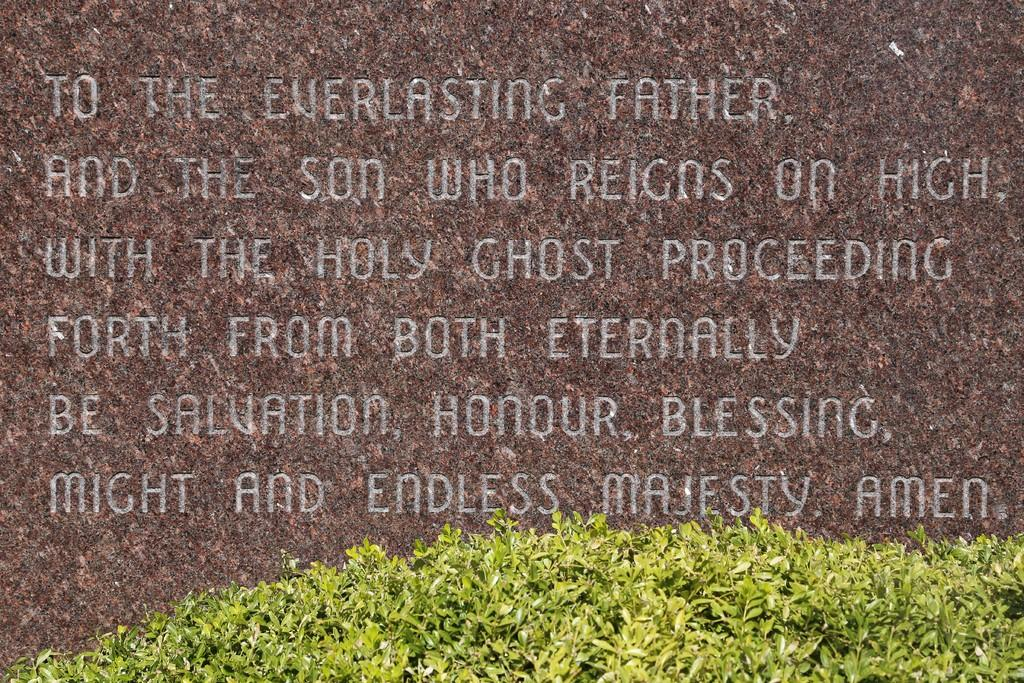What type of living organisms can be seen in the image? Plants can be seen in the image. Where are the plants located in the image? The plants are at the bottom of the image. What can be seen in the background of the image? There is a stone in the background of the image. What is written on the stone? Words are written on the stone. What type of sweater is being worn by the plant in the image? There is no sweater present in the image, as the subject is plants, which do not wear clothing. 